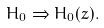Convert formula to latex. <formula><loc_0><loc_0><loc_500><loc_500>H _ { 0 } \Rightarrow H _ { 0 } ( z ) .</formula> 